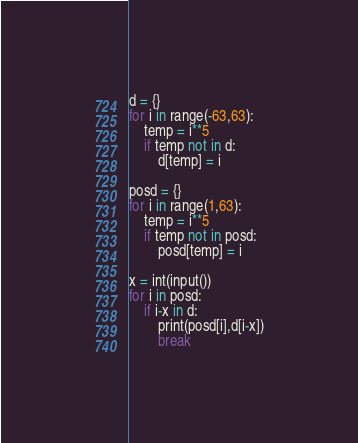Convert code to text. <code><loc_0><loc_0><loc_500><loc_500><_Python_>d = {}
for i in range(-63,63):
	temp = i**5
	if temp not in d:
		d[temp] = i

posd = {}
for i in range(1,63):
	temp = i**5
	if temp not in posd:
		posd[temp] = i

x = int(input())
for i in posd:
	if i-x in d:
		print(posd[i],d[i-x])
		break</code> 